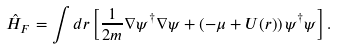<formula> <loc_0><loc_0><loc_500><loc_500>\hat { H } _ { F } = \int d { r } \left [ \frac { 1 } { 2 m } \nabla \psi ^ { \dagger } \nabla \psi + \left ( - \mu + U ( { r } ) \right ) \psi ^ { \dagger } \psi \right ] .</formula> 